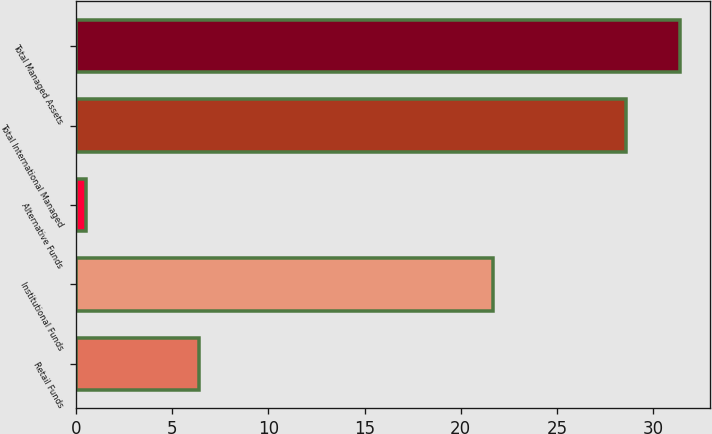Convert chart to OTSL. <chart><loc_0><loc_0><loc_500><loc_500><bar_chart><fcel>Retail Funds<fcel>Institutional Funds<fcel>Alternative Funds<fcel>Total International Managed<fcel>Total Managed Assets<nl><fcel>6.4<fcel>21.7<fcel>0.5<fcel>28.6<fcel>31.41<nl></chart> 